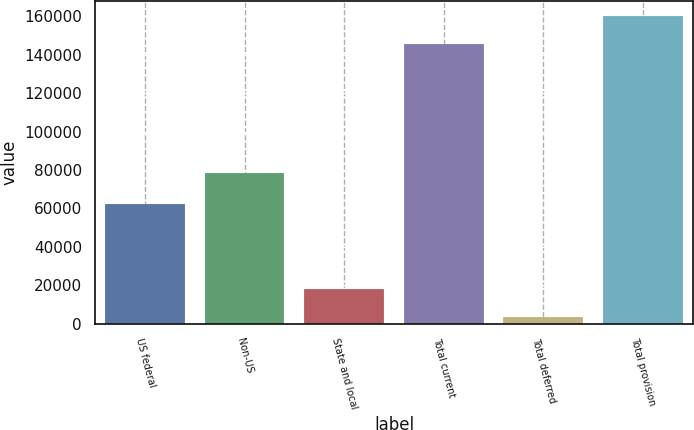Convert chart. <chart><loc_0><loc_0><loc_500><loc_500><bar_chart><fcel>US federal<fcel>Non-US<fcel>State and local<fcel>Total current<fcel>Total deferred<fcel>Total provision<nl><fcel>62032<fcel>78489<fcel>18000.8<fcel>145468<fcel>3454<fcel>160015<nl></chart> 